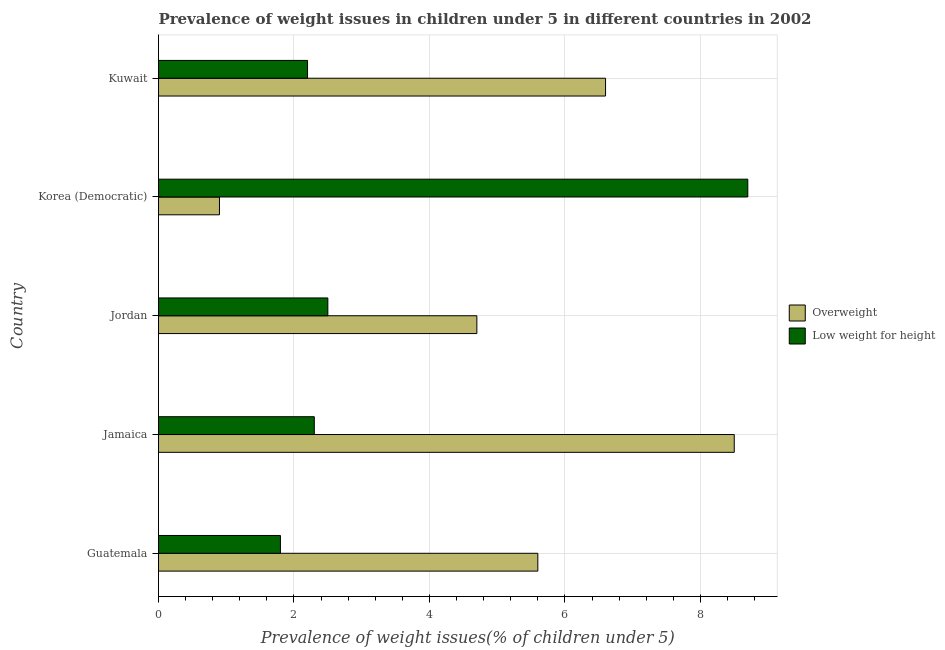How many different coloured bars are there?
Ensure brevity in your answer.  2. Are the number of bars on each tick of the Y-axis equal?
Your answer should be compact. Yes. What is the label of the 3rd group of bars from the top?
Your answer should be very brief. Jordan. What is the percentage of overweight children in Kuwait?
Make the answer very short. 6.6. Across all countries, what is the minimum percentage of overweight children?
Make the answer very short. 0.9. In which country was the percentage of underweight children maximum?
Give a very brief answer. Korea (Democratic). In which country was the percentage of overweight children minimum?
Give a very brief answer. Korea (Democratic). What is the total percentage of overweight children in the graph?
Provide a succinct answer. 26.3. What is the difference between the percentage of underweight children in Jamaica and the percentage of overweight children in Korea (Democratic)?
Your answer should be compact. 1.4. What is the average percentage of overweight children per country?
Your answer should be very brief. 5.26. What is the ratio of the percentage of underweight children in Guatemala to that in Jamaica?
Offer a very short reply. 0.78. Is the percentage of overweight children in Jordan less than that in Kuwait?
Your response must be concise. Yes. What is the difference between the highest and the lowest percentage of underweight children?
Provide a short and direct response. 6.9. Is the sum of the percentage of overweight children in Jordan and Korea (Democratic) greater than the maximum percentage of underweight children across all countries?
Ensure brevity in your answer.  No. What does the 1st bar from the top in Guatemala represents?
Offer a very short reply. Low weight for height. What does the 2nd bar from the bottom in Jamaica represents?
Provide a short and direct response. Low weight for height. How many bars are there?
Your answer should be compact. 10. Are all the bars in the graph horizontal?
Keep it short and to the point. Yes. Does the graph contain grids?
Provide a short and direct response. Yes. Where does the legend appear in the graph?
Provide a succinct answer. Center right. What is the title of the graph?
Keep it short and to the point. Prevalence of weight issues in children under 5 in different countries in 2002. What is the label or title of the X-axis?
Your response must be concise. Prevalence of weight issues(% of children under 5). What is the Prevalence of weight issues(% of children under 5) of Overweight in Guatemala?
Your answer should be compact. 5.6. What is the Prevalence of weight issues(% of children under 5) of Low weight for height in Guatemala?
Ensure brevity in your answer.  1.8. What is the Prevalence of weight issues(% of children under 5) in Low weight for height in Jamaica?
Provide a succinct answer. 2.3. What is the Prevalence of weight issues(% of children under 5) in Overweight in Jordan?
Offer a terse response. 4.7. What is the Prevalence of weight issues(% of children under 5) of Low weight for height in Jordan?
Offer a terse response. 2.5. What is the Prevalence of weight issues(% of children under 5) of Overweight in Korea (Democratic)?
Keep it short and to the point. 0.9. What is the Prevalence of weight issues(% of children under 5) in Low weight for height in Korea (Democratic)?
Give a very brief answer. 8.7. What is the Prevalence of weight issues(% of children under 5) of Overweight in Kuwait?
Your answer should be very brief. 6.6. What is the Prevalence of weight issues(% of children under 5) of Low weight for height in Kuwait?
Your response must be concise. 2.2. Across all countries, what is the maximum Prevalence of weight issues(% of children under 5) in Low weight for height?
Make the answer very short. 8.7. Across all countries, what is the minimum Prevalence of weight issues(% of children under 5) in Overweight?
Make the answer very short. 0.9. Across all countries, what is the minimum Prevalence of weight issues(% of children under 5) in Low weight for height?
Make the answer very short. 1.8. What is the total Prevalence of weight issues(% of children under 5) in Overweight in the graph?
Give a very brief answer. 26.3. What is the difference between the Prevalence of weight issues(% of children under 5) in Overweight in Guatemala and that in Jordan?
Your answer should be compact. 0.9. What is the difference between the Prevalence of weight issues(% of children under 5) in Overweight in Guatemala and that in Korea (Democratic)?
Provide a succinct answer. 4.7. What is the difference between the Prevalence of weight issues(% of children under 5) in Overweight in Guatemala and that in Kuwait?
Provide a succinct answer. -1. What is the difference between the Prevalence of weight issues(% of children under 5) in Low weight for height in Guatemala and that in Kuwait?
Your response must be concise. -0.4. What is the difference between the Prevalence of weight issues(% of children under 5) in Low weight for height in Jamaica and that in Jordan?
Keep it short and to the point. -0.2. What is the difference between the Prevalence of weight issues(% of children under 5) of Overweight in Jamaica and that in Korea (Democratic)?
Your response must be concise. 7.6. What is the difference between the Prevalence of weight issues(% of children under 5) in Low weight for height in Jamaica and that in Korea (Democratic)?
Your response must be concise. -6.4. What is the difference between the Prevalence of weight issues(% of children under 5) in Overweight in Jamaica and that in Kuwait?
Provide a short and direct response. 1.9. What is the difference between the Prevalence of weight issues(% of children under 5) of Overweight in Jordan and that in Korea (Democratic)?
Your answer should be very brief. 3.8. What is the difference between the Prevalence of weight issues(% of children under 5) in Low weight for height in Jordan and that in Korea (Democratic)?
Keep it short and to the point. -6.2. What is the difference between the Prevalence of weight issues(% of children under 5) in Overweight in Jordan and that in Kuwait?
Your answer should be very brief. -1.9. What is the difference between the Prevalence of weight issues(% of children under 5) of Low weight for height in Jordan and that in Kuwait?
Provide a succinct answer. 0.3. What is the difference between the Prevalence of weight issues(% of children under 5) in Overweight in Korea (Democratic) and that in Kuwait?
Your answer should be very brief. -5.7. What is the difference between the Prevalence of weight issues(% of children under 5) of Low weight for height in Korea (Democratic) and that in Kuwait?
Offer a very short reply. 6.5. What is the difference between the Prevalence of weight issues(% of children under 5) in Overweight in Guatemala and the Prevalence of weight issues(% of children under 5) in Low weight for height in Jamaica?
Your answer should be very brief. 3.3. What is the difference between the Prevalence of weight issues(% of children under 5) of Overweight in Guatemala and the Prevalence of weight issues(% of children under 5) of Low weight for height in Korea (Democratic)?
Ensure brevity in your answer.  -3.1. What is the difference between the Prevalence of weight issues(% of children under 5) in Overweight in Jamaica and the Prevalence of weight issues(% of children under 5) in Low weight for height in Jordan?
Keep it short and to the point. 6. What is the difference between the Prevalence of weight issues(% of children under 5) in Overweight in Jamaica and the Prevalence of weight issues(% of children under 5) in Low weight for height in Korea (Democratic)?
Ensure brevity in your answer.  -0.2. What is the average Prevalence of weight issues(% of children under 5) in Overweight per country?
Ensure brevity in your answer.  5.26. What is the difference between the Prevalence of weight issues(% of children under 5) of Overweight and Prevalence of weight issues(% of children under 5) of Low weight for height in Korea (Democratic)?
Your answer should be very brief. -7.8. What is the ratio of the Prevalence of weight issues(% of children under 5) in Overweight in Guatemala to that in Jamaica?
Give a very brief answer. 0.66. What is the ratio of the Prevalence of weight issues(% of children under 5) of Low weight for height in Guatemala to that in Jamaica?
Keep it short and to the point. 0.78. What is the ratio of the Prevalence of weight issues(% of children under 5) in Overweight in Guatemala to that in Jordan?
Ensure brevity in your answer.  1.19. What is the ratio of the Prevalence of weight issues(% of children under 5) of Low weight for height in Guatemala to that in Jordan?
Your answer should be compact. 0.72. What is the ratio of the Prevalence of weight issues(% of children under 5) in Overweight in Guatemala to that in Korea (Democratic)?
Offer a very short reply. 6.22. What is the ratio of the Prevalence of weight issues(% of children under 5) in Low weight for height in Guatemala to that in Korea (Democratic)?
Your response must be concise. 0.21. What is the ratio of the Prevalence of weight issues(% of children under 5) of Overweight in Guatemala to that in Kuwait?
Keep it short and to the point. 0.85. What is the ratio of the Prevalence of weight issues(% of children under 5) in Low weight for height in Guatemala to that in Kuwait?
Make the answer very short. 0.82. What is the ratio of the Prevalence of weight issues(% of children under 5) in Overweight in Jamaica to that in Jordan?
Your answer should be compact. 1.81. What is the ratio of the Prevalence of weight issues(% of children under 5) of Low weight for height in Jamaica to that in Jordan?
Your response must be concise. 0.92. What is the ratio of the Prevalence of weight issues(% of children under 5) in Overweight in Jamaica to that in Korea (Democratic)?
Your answer should be very brief. 9.44. What is the ratio of the Prevalence of weight issues(% of children under 5) in Low weight for height in Jamaica to that in Korea (Democratic)?
Give a very brief answer. 0.26. What is the ratio of the Prevalence of weight issues(% of children under 5) in Overweight in Jamaica to that in Kuwait?
Keep it short and to the point. 1.29. What is the ratio of the Prevalence of weight issues(% of children under 5) in Low weight for height in Jamaica to that in Kuwait?
Your answer should be compact. 1.05. What is the ratio of the Prevalence of weight issues(% of children under 5) in Overweight in Jordan to that in Korea (Democratic)?
Give a very brief answer. 5.22. What is the ratio of the Prevalence of weight issues(% of children under 5) in Low weight for height in Jordan to that in Korea (Democratic)?
Make the answer very short. 0.29. What is the ratio of the Prevalence of weight issues(% of children under 5) of Overweight in Jordan to that in Kuwait?
Make the answer very short. 0.71. What is the ratio of the Prevalence of weight issues(% of children under 5) of Low weight for height in Jordan to that in Kuwait?
Your answer should be compact. 1.14. What is the ratio of the Prevalence of weight issues(% of children under 5) of Overweight in Korea (Democratic) to that in Kuwait?
Keep it short and to the point. 0.14. What is the ratio of the Prevalence of weight issues(% of children under 5) of Low weight for height in Korea (Democratic) to that in Kuwait?
Provide a short and direct response. 3.95. What is the difference between the highest and the lowest Prevalence of weight issues(% of children under 5) in Overweight?
Your answer should be compact. 7.6. 